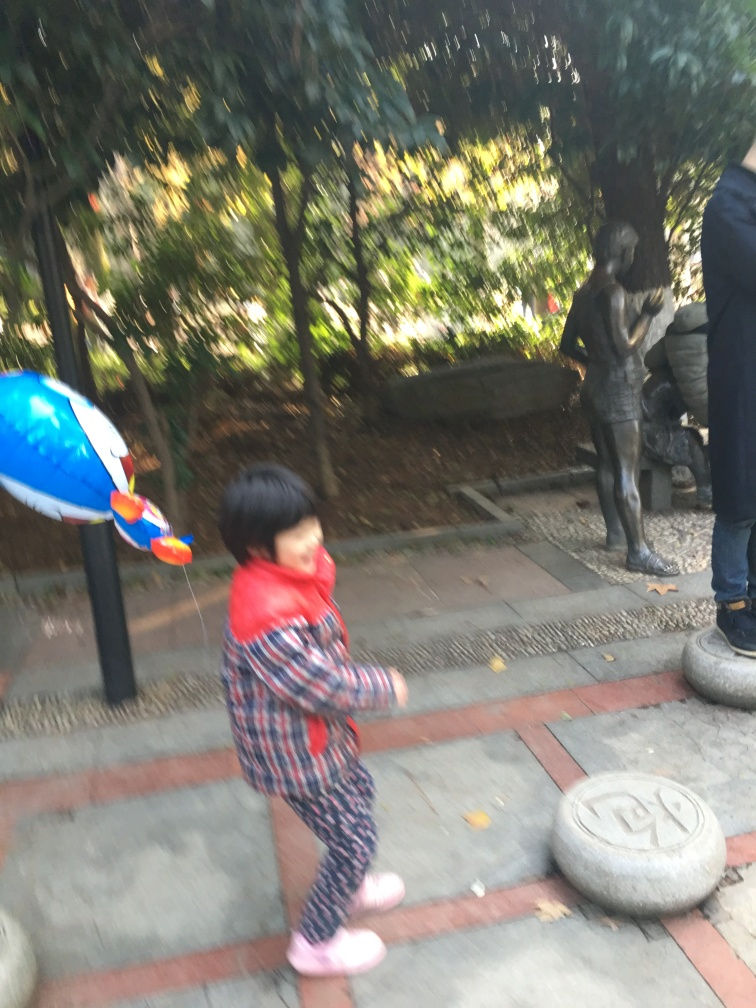What is the overall clarity of this image?
A. Average
B. Moderate
C. High
D. Very low. The overall clarity of this image would be classified as very low. The main subjects are not in sharp focus, and there appears to be significant blurring across the entire image, which suggests movement or camera shake during the capture. The lack of clear detail prevents a viewer from easily making out finer features in the scene. 